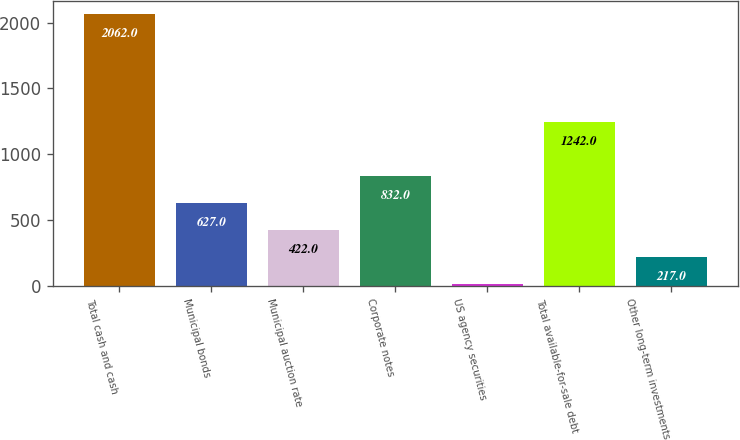Convert chart to OTSL. <chart><loc_0><loc_0><loc_500><loc_500><bar_chart><fcel>Total cash and cash<fcel>Municipal bonds<fcel>Municipal auction rate<fcel>Corporate notes<fcel>US agency securities<fcel>Total available-for-sale debt<fcel>Other long-term investments<nl><fcel>2062<fcel>627<fcel>422<fcel>832<fcel>12<fcel>1242<fcel>217<nl></chart> 